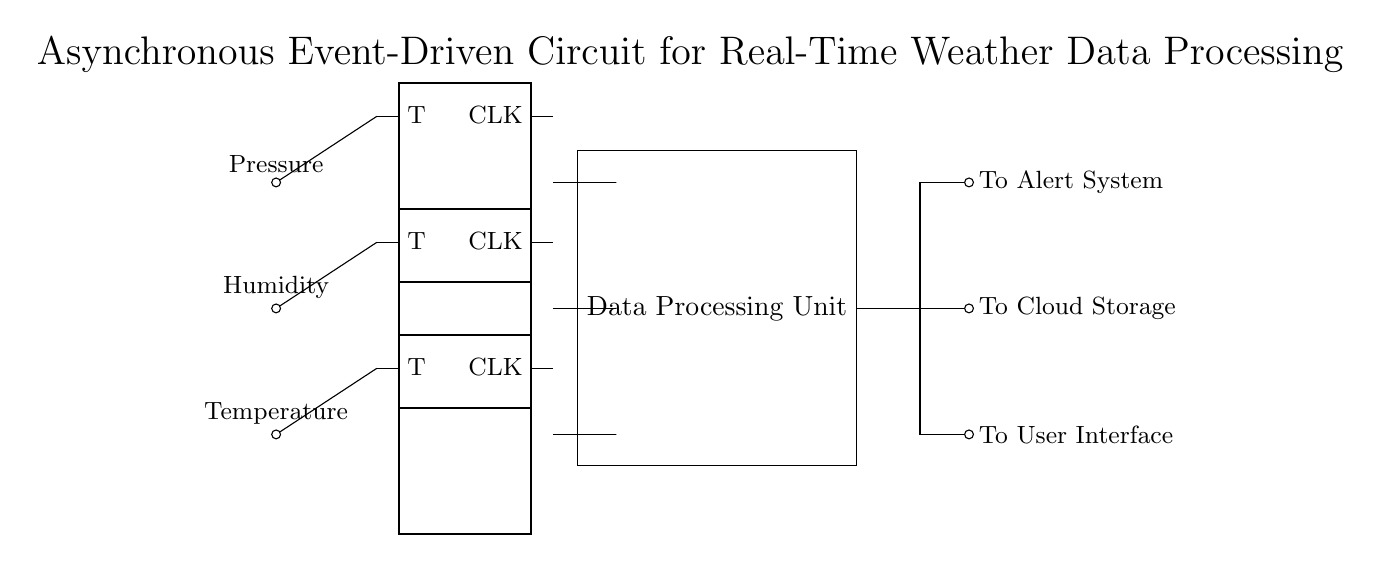What components are used in this circuit? The circuit includes weather sensors, flip-flops, a data processing unit, and output interfaces.
Answer: weather sensors, flip-flops, data processing unit, output interfaces What type of data do the sensors collect? The sensors are labeled to collect temperature, humidity, and pressure data.
Answer: temperature, humidity, pressure How many flip-flops are present in the circuit? There are three flip-flops in the circuit, each positioned next to a weather sensor.
Answer: three What is the main function of the data processing unit? The data processing unit processes the data received from the flip-flops before sending it to the output interfaces.
Answer: processes data What is the output from the first output interface? The first output interface is directed toward the user interface, as indicated in the diagram.
Answer: To User Interface How does the circuit achieve asynchronous event-driven processing? Asynchronous event-driven processing is achieved by using flip-flops to handle data from sensors independently, allowing real-time responses to changes.
Answer: flip-flops handle data independently What outputs are directed towards the alert system? The third output interface is specifically directed to the alert system in the circuit.
Answer: To Alert System 